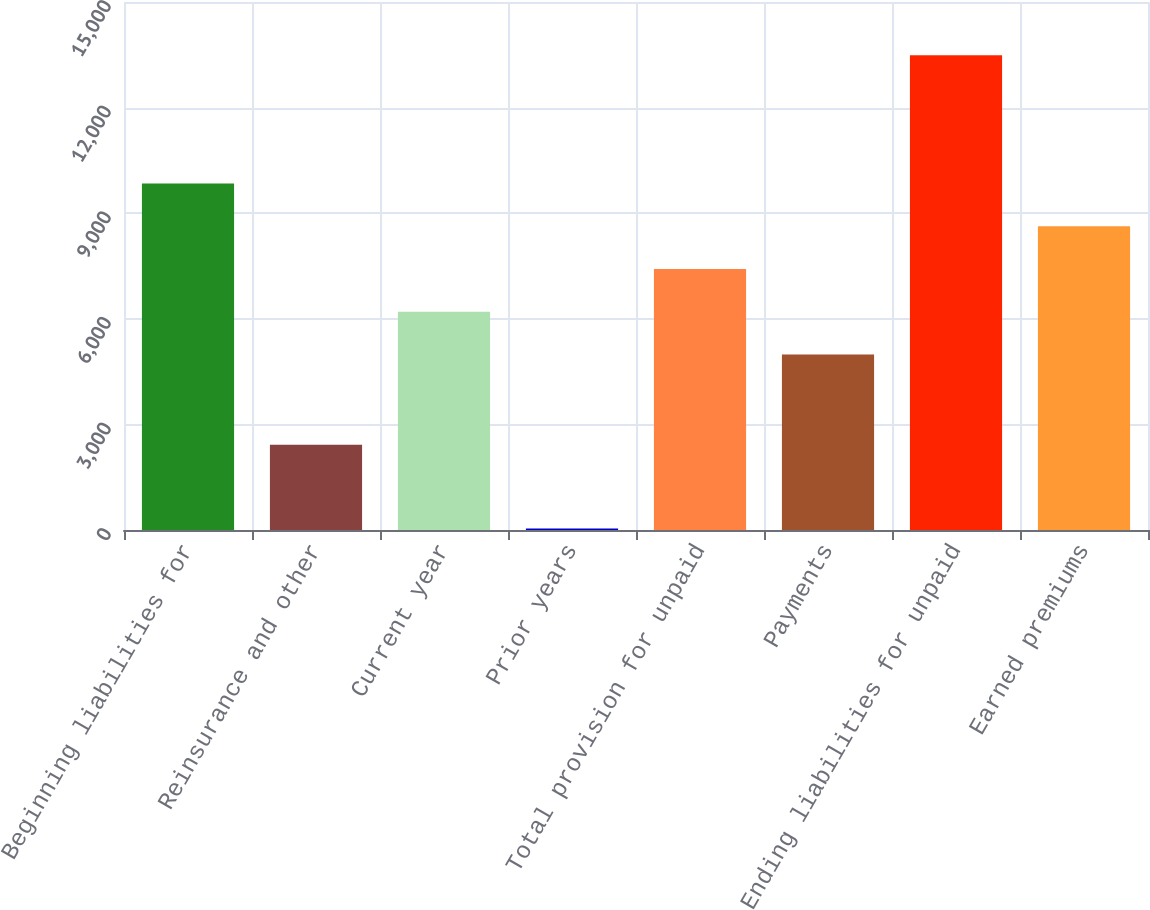Convert chart. <chart><loc_0><loc_0><loc_500><loc_500><bar_chart><fcel>Beginning liabilities for<fcel>Reinsurance and other<fcel>Current year<fcel>Prior years<fcel>Total provision for unpaid<fcel>Payments<fcel>Ending liabilities for unpaid<fcel>Earned premiums<nl><fcel>9843.8<fcel>2422<fcel>6202.7<fcel>40<fcel>7416.4<fcel>4989<fcel>13484.9<fcel>8630.1<nl></chart> 